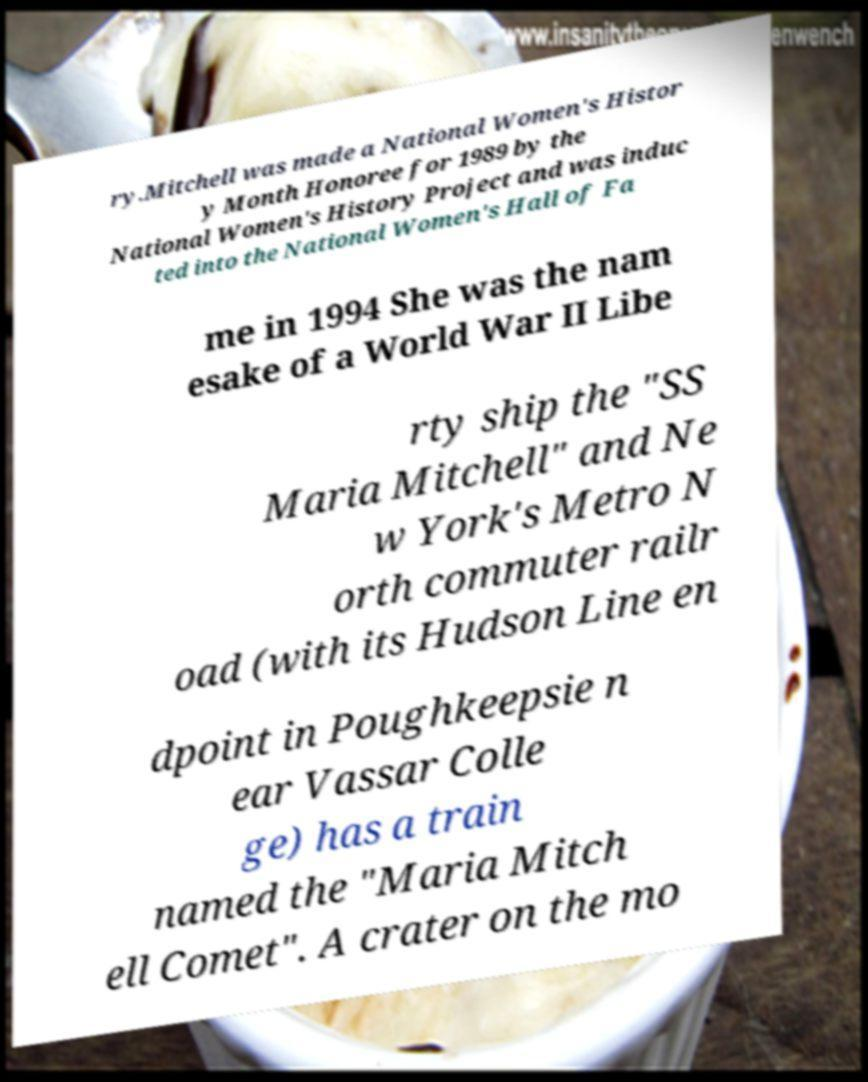There's text embedded in this image that I need extracted. Can you transcribe it verbatim? ry.Mitchell was made a National Women's Histor y Month Honoree for 1989 by the National Women's History Project and was induc ted into the National Women's Hall of Fa me in 1994 She was the nam esake of a World War II Libe rty ship the "SS Maria Mitchell" and Ne w York's Metro N orth commuter railr oad (with its Hudson Line en dpoint in Poughkeepsie n ear Vassar Colle ge) has a train named the "Maria Mitch ell Comet". A crater on the mo 